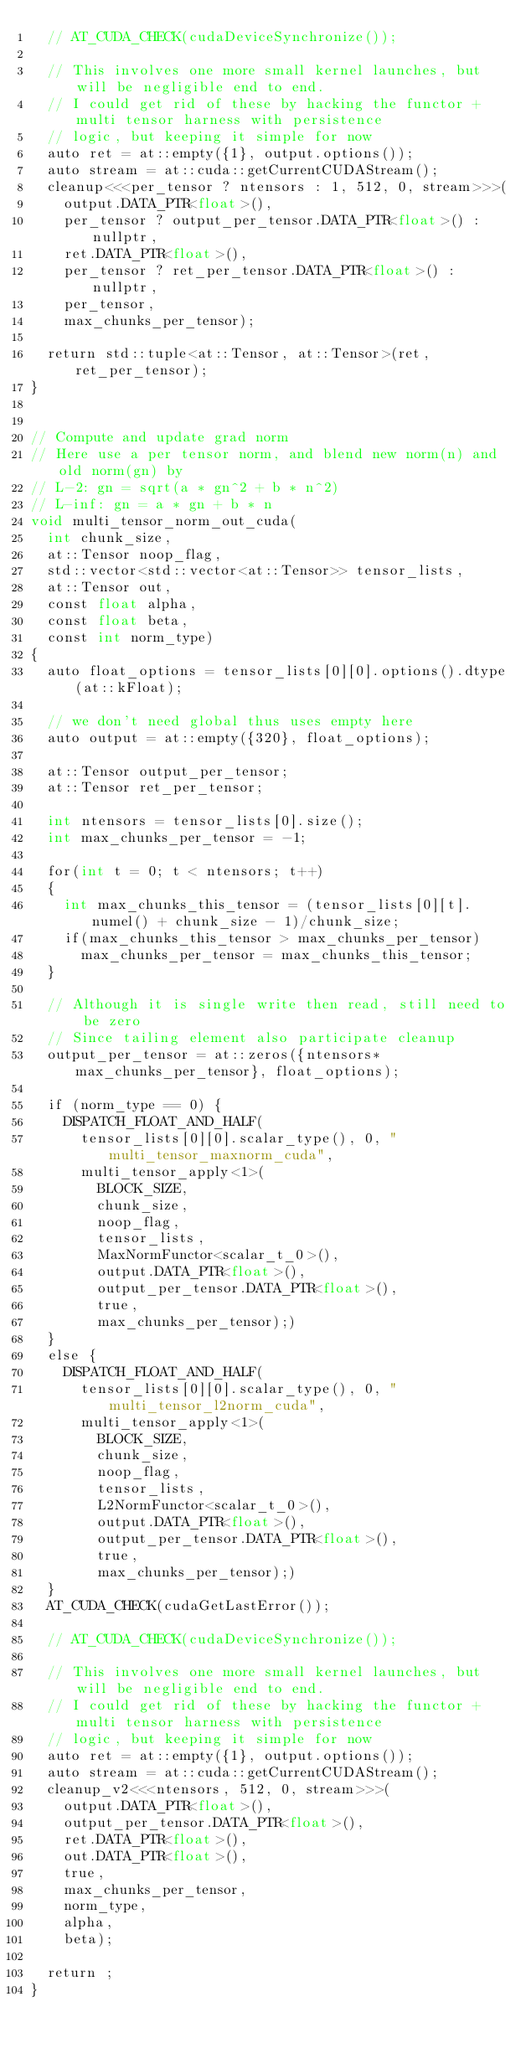Convert code to text. <code><loc_0><loc_0><loc_500><loc_500><_Cuda_>  // AT_CUDA_CHECK(cudaDeviceSynchronize());

  // This involves one more small kernel launches, but will be negligible end to end.
  // I could get rid of these by hacking the functor + multi tensor harness with persistence
  // logic, but keeping it simple for now
  auto ret = at::empty({1}, output.options());
  auto stream = at::cuda::getCurrentCUDAStream();
  cleanup<<<per_tensor ? ntensors : 1, 512, 0, stream>>>(
    output.DATA_PTR<float>(),
    per_tensor ? output_per_tensor.DATA_PTR<float>() : nullptr,
    ret.DATA_PTR<float>(),
    per_tensor ? ret_per_tensor.DATA_PTR<float>() : nullptr,
    per_tensor,
    max_chunks_per_tensor);

  return std::tuple<at::Tensor, at::Tensor>(ret, ret_per_tensor);
}


// Compute and update grad norm
// Here use a per tensor norm, and blend new norm(n) and old norm(gn) by
// L-2: gn = sqrt(a * gn^2 + b * n^2)
// L-inf: gn = a * gn + b * n
void multi_tensor_norm_out_cuda(
  int chunk_size,
  at::Tensor noop_flag,
  std::vector<std::vector<at::Tensor>> tensor_lists,
  at::Tensor out,
  const float alpha,
  const float beta,
  const int norm_type)
{
  auto float_options = tensor_lists[0][0].options().dtype(at::kFloat);

  // we don't need global thus uses empty here
  auto output = at::empty({320}, float_options);

  at::Tensor output_per_tensor;
  at::Tensor ret_per_tensor;

  int ntensors = tensor_lists[0].size();
  int max_chunks_per_tensor = -1;

  for(int t = 0; t < ntensors; t++)
  {
    int max_chunks_this_tensor = (tensor_lists[0][t].numel() + chunk_size - 1)/chunk_size;
    if(max_chunks_this_tensor > max_chunks_per_tensor)
      max_chunks_per_tensor = max_chunks_this_tensor;
  }

  // Although it is single write then read, still need to be zero
  // Since tailing element also participate cleanup
  output_per_tensor = at::zeros({ntensors*max_chunks_per_tensor}, float_options);

  if (norm_type == 0) {
    DISPATCH_FLOAT_AND_HALF(
      tensor_lists[0][0].scalar_type(), 0, "multi_tensor_maxnorm_cuda",
      multi_tensor_apply<1>(
        BLOCK_SIZE,
        chunk_size,
        noop_flag,
        tensor_lists,
        MaxNormFunctor<scalar_t_0>(),
        output.DATA_PTR<float>(),
        output_per_tensor.DATA_PTR<float>(),
        true,
        max_chunks_per_tensor);)
  }
  else {
    DISPATCH_FLOAT_AND_HALF(
      tensor_lists[0][0].scalar_type(), 0, "multi_tensor_l2norm_cuda",
      multi_tensor_apply<1>(
        BLOCK_SIZE,
        chunk_size,
        noop_flag,
        tensor_lists,
        L2NormFunctor<scalar_t_0>(),
        output.DATA_PTR<float>(),
        output_per_tensor.DATA_PTR<float>(),
        true,
        max_chunks_per_tensor);)
  }
  AT_CUDA_CHECK(cudaGetLastError());

  // AT_CUDA_CHECK(cudaDeviceSynchronize());

  // This involves one more small kernel launches, but will be negligible end to end.
  // I could get rid of these by hacking the functor + multi tensor harness with persistence
  // logic, but keeping it simple for now
  auto ret = at::empty({1}, output.options());
  auto stream = at::cuda::getCurrentCUDAStream();
  cleanup_v2<<<ntensors, 512, 0, stream>>>(
    output.DATA_PTR<float>(),
    output_per_tensor.DATA_PTR<float>(),
    ret.DATA_PTR<float>(),
    out.DATA_PTR<float>(),
    true,
    max_chunks_per_tensor,
    norm_type,
    alpha,
    beta);

  return ;
}
</code> 